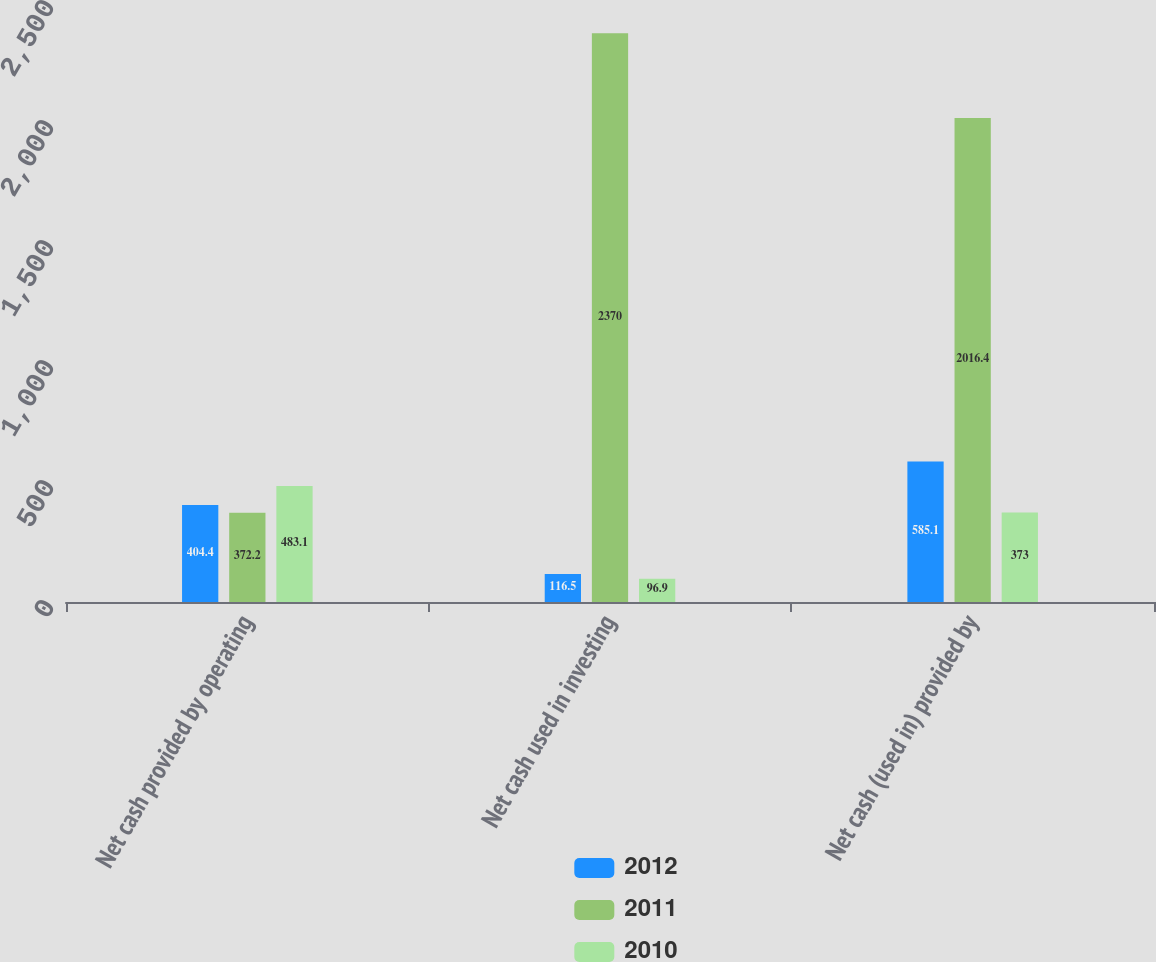Convert chart to OTSL. <chart><loc_0><loc_0><loc_500><loc_500><stacked_bar_chart><ecel><fcel>Net cash provided by operating<fcel>Net cash used in investing<fcel>Net cash (used in) provided by<nl><fcel>2012<fcel>404.4<fcel>116.5<fcel>585.1<nl><fcel>2011<fcel>372.2<fcel>2370<fcel>2016.4<nl><fcel>2010<fcel>483.1<fcel>96.9<fcel>373<nl></chart> 